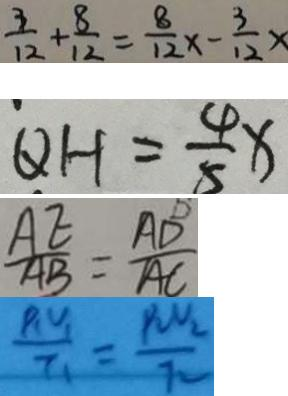Convert formula to latex. <formula><loc_0><loc_0><loc_500><loc_500>\frac { 3 } { 1 2 } + \frac { 8 } { 1 2 } = \frac { 8 } { 1 2 } x - \frac { 3 } { 1 2 } x 
 Q H = \frac { 4 } { 5 } x 
 \frac { A E } { A B } = \frac { A D } { A C } 
 \frac { P _ { 1 } V _ { 1 } } { I _ { 1 } } = \frac { P _ { 2 } V _ { 2 } } { I _ { 2 } }</formula> 